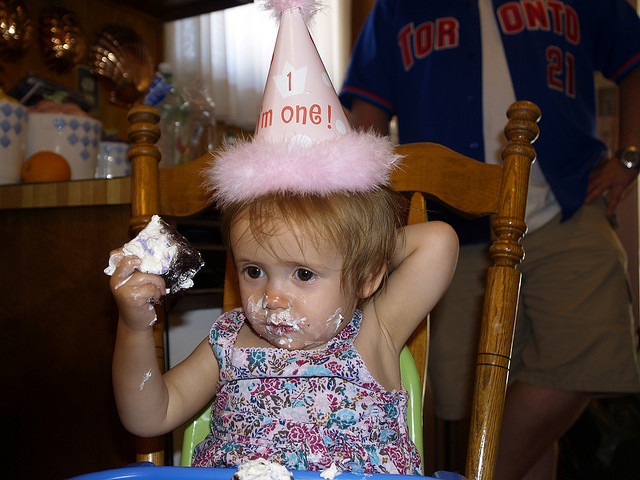Read all the text in this image. 1 one TUR 21 ON m 